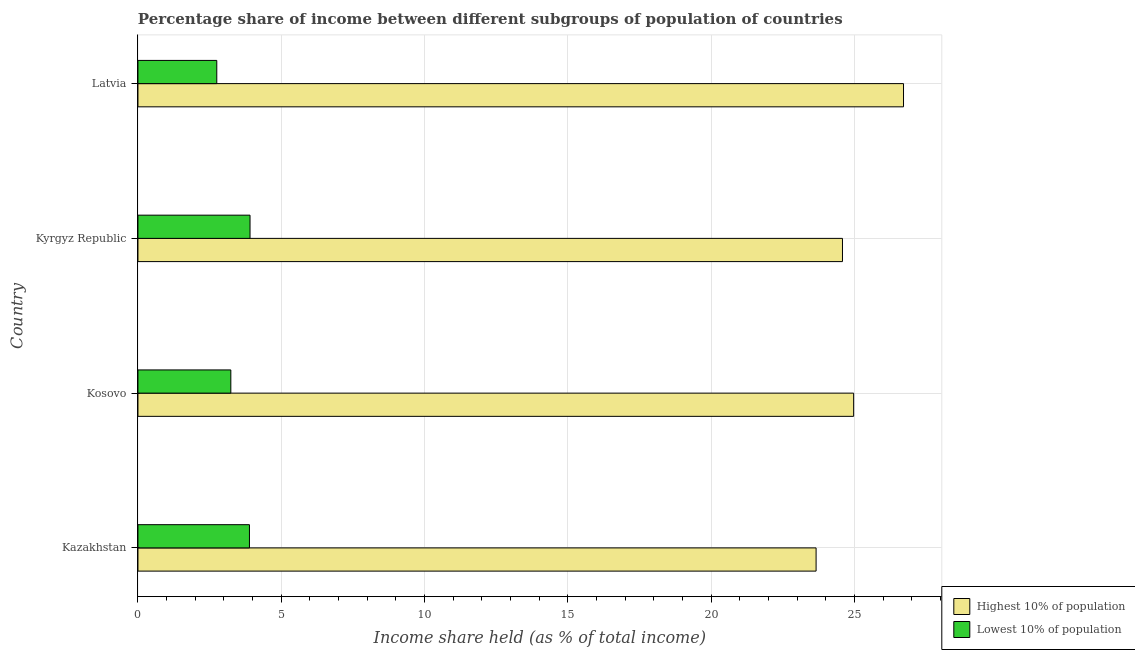How many groups of bars are there?
Your answer should be compact. 4. Are the number of bars per tick equal to the number of legend labels?
Give a very brief answer. Yes. Are the number of bars on each tick of the Y-axis equal?
Your answer should be very brief. Yes. How many bars are there on the 1st tick from the bottom?
Provide a succinct answer. 2. What is the label of the 2nd group of bars from the top?
Provide a succinct answer. Kyrgyz Republic. In how many cases, is the number of bars for a given country not equal to the number of legend labels?
Offer a very short reply. 0. What is the income share held by highest 10% of the population in Latvia?
Ensure brevity in your answer.  26.71. Across all countries, what is the maximum income share held by lowest 10% of the population?
Ensure brevity in your answer.  3.91. Across all countries, what is the minimum income share held by lowest 10% of the population?
Provide a succinct answer. 2.75. In which country was the income share held by highest 10% of the population maximum?
Your response must be concise. Latvia. In which country was the income share held by lowest 10% of the population minimum?
Provide a short and direct response. Latvia. What is the total income share held by highest 10% of the population in the graph?
Your response must be concise. 99.92. What is the difference between the income share held by highest 10% of the population in Kyrgyz Republic and that in Latvia?
Offer a very short reply. -2.13. What is the difference between the income share held by lowest 10% of the population in Kyrgyz Republic and the income share held by highest 10% of the population in Kosovo?
Your answer should be very brief. -21.06. What is the average income share held by lowest 10% of the population per country?
Provide a short and direct response. 3.45. What is the difference between the income share held by lowest 10% of the population and income share held by highest 10% of the population in Kazakhstan?
Ensure brevity in your answer.  -19.77. In how many countries, is the income share held by lowest 10% of the population greater than 25 %?
Offer a very short reply. 0. What is the ratio of the income share held by lowest 10% of the population in Kyrgyz Republic to that in Latvia?
Ensure brevity in your answer.  1.42. Is the difference between the income share held by lowest 10% of the population in Kyrgyz Republic and Latvia greater than the difference between the income share held by highest 10% of the population in Kyrgyz Republic and Latvia?
Make the answer very short. Yes. What is the difference between the highest and the second highest income share held by lowest 10% of the population?
Provide a short and direct response. 0.02. What is the difference between the highest and the lowest income share held by highest 10% of the population?
Ensure brevity in your answer.  3.05. In how many countries, is the income share held by highest 10% of the population greater than the average income share held by highest 10% of the population taken over all countries?
Provide a succinct answer. 1. Is the sum of the income share held by lowest 10% of the population in Kyrgyz Republic and Latvia greater than the maximum income share held by highest 10% of the population across all countries?
Provide a short and direct response. No. What does the 1st bar from the top in Kyrgyz Republic represents?
Ensure brevity in your answer.  Lowest 10% of population. What does the 2nd bar from the bottom in Kazakhstan represents?
Give a very brief answer. Lowest 10% of population. How many bars are there?
Give a very brief answer. 8. How many countries are there in the graph?
Give a very brief answer. 4. What is the difference between two consecutive major ticks on the X-axis?
Keep it short and to the point. 5. Does the graph contain grids?
Your answer should be compact. Yes. What is the title of the graph?
Your answer should be compact. Percentage share of income between different subgroups of population of countries. What is the label or title of the X-axis?
Provide a short and direct response. Income share held (as % of total income). What is the Income share held (as % of total income) in Highest 10% of population in Kazakhstan?
Your answer should be very brief. 23.66. What is the Income share held (as % of total income) in Lowest 10% of population in Kazakhstan?
Offer a very short reply. 3.89. What is the Income share held (as % of total income) of Highest 10% of population in Kosovo?
Your response must be concise. 24.97. What is the Income share held (as % of total income) of Lowest 10% of population in Kosovo?
Give a very brief answer. 3.24. What is the Income share held (as % of total income) of Highest 10% of population in Kyrgyz Republic?
Offer a very short reply. 24.58. What is the Income share held (as % of total income) of Lowest 10% of population in Kyrgyz Republic?
Provide a succinct answer. 3.91. What is the Income share held (as % of total income) of Highest 10% of population in Latvia?
Your response must be concise. 26.71. What is the Income share held (as % of total income) of Lowest 10% of population in Latvia?
Offer a terse response. 2.75. Across all countries, what is the maximum Income share held (as % of total income) of Highest 10% of population?
Offer a very short reply. 26.71. Across all countries, what is the maximum Income share held (as % of total income) in Lowest 10% of population?
Make the answer very short. 3.91. Across all countries, what is the minimum Income share held (as % of total income) of Highest 10% of population?
Offer a terse response. 23.66. Across all countries, what is the minimum Income share held (as % of total income) in Lowest 10% of population?
Your answer should be very brief. 2.75. What is the total Income share held (as % of total income) in Highest 10% of population in the graph?
Your answer should be compact. 99.92. What is the total Income share held (as % of total income) of Lowest 10% of population in the graph?
Provide a succinct answer. 13.79. What is the difference between the Income share held (as % of total income) in Highest 10% of population in Kazakhstan and that in Kosovo?
Offer a terse response. -1.31. What is the difference between the Income share held (as % of total income) of Lowest 10% of population in Kazakhstan and that in Kosovo?
Make the answer very short. 0.65. What is the difference between the Income share held (as % of total income) in Highest 10% of population in Kazakhstan and that in Kyrgyz Republic?
Make the answer very short. -0.92. What is the difference between the Income share held (as % of total income) of Lowest 10% of population in Kazakhstan and that in Kyrgyz Republic?
Ensure brevity in your answer.  -0.02. What is the difference between the Income share held (as % of total income) of Highest 10% of population in Kazakhstan and that in Latvia?
Make the answer very short. -3.05. What is the difference between the Income share held (as % of total income) of Lowest 10% of population in Kazakhstan and that in Latvia?
Your answer should be very brief. 1.14. What is the difference between the Income share held (as % of total income) in Highest 10% of population in Kosovo and that in Kyrgyz Republic?
Ensure brevity in your answer.  0.39. What is the difference between the Income share held (as % of total income) of Lowest 10% of population in Kosovo and that in Kyrgyz Republic?
Offer a terse response. -0.67. What is the difference between the Income share held (as % of total income) in Highest 10% of population in Kosovo and that in Latvia?
Ensure brevity in your answer.  -1.74. What is the difference between the Income share held (as % of total income) in Lowest 10% of population in Kosovo and that in Latvia?
Your answer should be compact. 0.49. What is the difference between the Income share held (as % of total income) in Highest 10% of population in Kyrgyz Republic and that in Latvia?
Offer a terse response. -2.13. What is the difference between the Income share held (as % of total income) of Lowest 10% of population in Kyrgyz Republic and that in Latvia?
Ensure brevity in your answer.  1.16. What is the difference between the Income share held (as % of total income) in Highest 10% of population in Kazakhstan and the Income share held (as % of total income) in Lowest 10% of population in Kosovo?
Give a very brief answer. 20.42. What is the difference between the Income share held (as % of total income) in Highest 10% of population in Kazakhstan and the Income share held (as % of total income) in Lowest 10% of population in Kyrgyz Republic?
Your answer should be compact. 19.75. What is the difference between the Income share held (as % of total income) of Highest 10% of population in Kazakhstan and the Income share held (as % of total income) of Lowest 10% of population in Latvia?
Give a very brief answer. 20.91. What is the difference between the Income share held (as % of total income) in Highest 10% of population in Kosovo and the Income share held (as % of total income) in Lowest 10% of population in Kyrgyz Republic?
Provide a succinct answer. 21.06. What is the difference between the Income share held (as % of total income) of Highest 10% of population in Kosovo and the Income share held (as % of total income) of Lowest 10% of population in Latvia?
Provide a short and direct response. 22.22. What is the difference between the Income share held (as % of total income) in Highest 10% of population in Kyrgyz Republic and the Income share held (as % of total income) in Lowest 10% of population in Latvia?
Your answer should be very brief. 21.83. What is the average Income share held (as % of total income) in Highest 10% of population per country?
Make the answer very short. 24.98. What is the average Income share held (as % of total income) in Lowest 10% of population per country?
Give a very brief answer. 3.45. What is the difference between the Income share held (as % of total income) of Highest 10% of population and Income share held (as % of total income) of Lowest 10% of population in Kazakhstan?
Offer a terse response. 19.77. What is the difference between the Income share held (as % of total income) of Highest 10% of population and Income share held (as % of total income) of Lowest 10% of population in Kosovo?
Provide a short and direct response. 21.73. What is the difference between the Income share held (as % of total income) of Highest 10% of population and Income share held (as % of total income) of Lowest 10% of population in Kyrgyz Republic?
Offer a terse response. 20.67. What is the difference between the Income share held (as % of total income) in Highest 10% of population and Income share held (as % of total income) in Lowest 10% of population in Latvia?
Your response must be concise. 23.96. What is the ratio of the Income share held (as % of total income) of Highest 10% of population in Kazakhstan to that in Kosovo?
Your answer should be very brief. 0.95. What is the ratio of the Income share held (as % of total income) in Lowest 10% of population in Kazakhstan to that in Kosovo?
Give a very brief answer. 1.2. What is the ratio of the Income share held (as % of total income) of Highest 10% of population in Kazakhstan to that in Kyrgyz Republic?
Provide a succinct answer. 0.96. What is the ratio of the Income share held (as % of total income) of Highest 10% of population in Kazakhstan to that in Latvia?
Your answer should be compact. 0.89. What is the ratio of the Income share held (as % of total income) of Lowest 10% of population in Kazakhstan to that in Latvia?
Ensure brevity in your answer.  1.41. What is the ratio of the Income share held (as % of total income) in Highest 10% of population in Kosovo to that in Kyrgyz Republic?
Your answer should be very brief. 1.02. What is the ratio of the Income share held (as % of total income) in Lowest 10% of population in Kosovo to that in Kyrgyz Republic?
Your response must be concise. 0.83. What is the ratio of the Income share held (as % of total income) of Highest 10% of population in Kosovo to that in Latvia?
Your response must be concise. 0.93. What is the ratio of the Income share held (as % of total income) in Lowest 10% of population in Kosovo to that in Latvia?
Provide a short and direct response. 1.18. What is the ratio of the Income share held (as % of total income) in Highest 10% of population in Kyrgyz Republic to that in Latvia?
Offer a terse response. 0.92. What is the ratio of the Income share held (as % of total income) of Lowest 10% of population in Kyrgyz Republic to that in Latvia?
Your answer should be compact. 1.42. What is the difference between the highest and the second highest Income share held (as % of total income) in Highest 10% of population?
Provide a succinct answer. 1.74. What is the difference between the highest and the second highest Income share held (as % of total income) of Lowest 10% of population?
Give a very brief answer. 0.02. What is the difference between the highest and the lowest Income share held (as % of total income) of Highest 10% of population?
Provide a succinct answer. 3.05. What is the difference between the highest and the lowest Income share held (as % of total income) in Lowest 10% of population?
Keep it short and to the point. 1.16. 